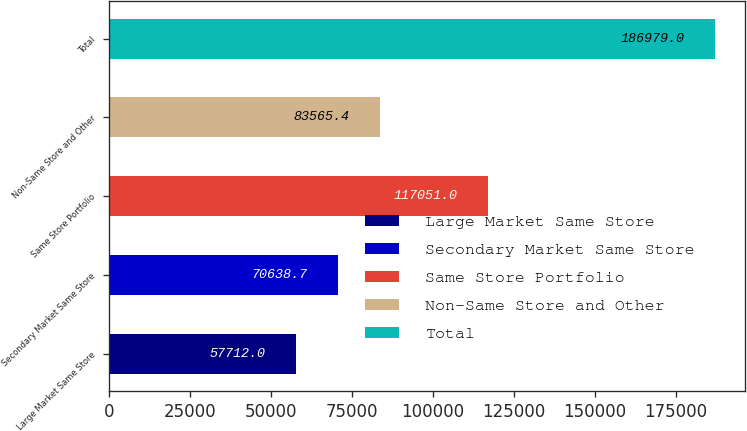Convert chart. <chart><loc_0><loc_0><loc_500><loc_500><bar_chart><fcel>Large Market Same Store<fcel>Secondary Market Same Store<fcel>Same Store Portfolio<fcel>Non-Same Store and Other<fcel>Total<nl><fcel>57712<fcel>70638.7<fcel>117051<fcel>83565.4<fcel>186979<nl></chart> 